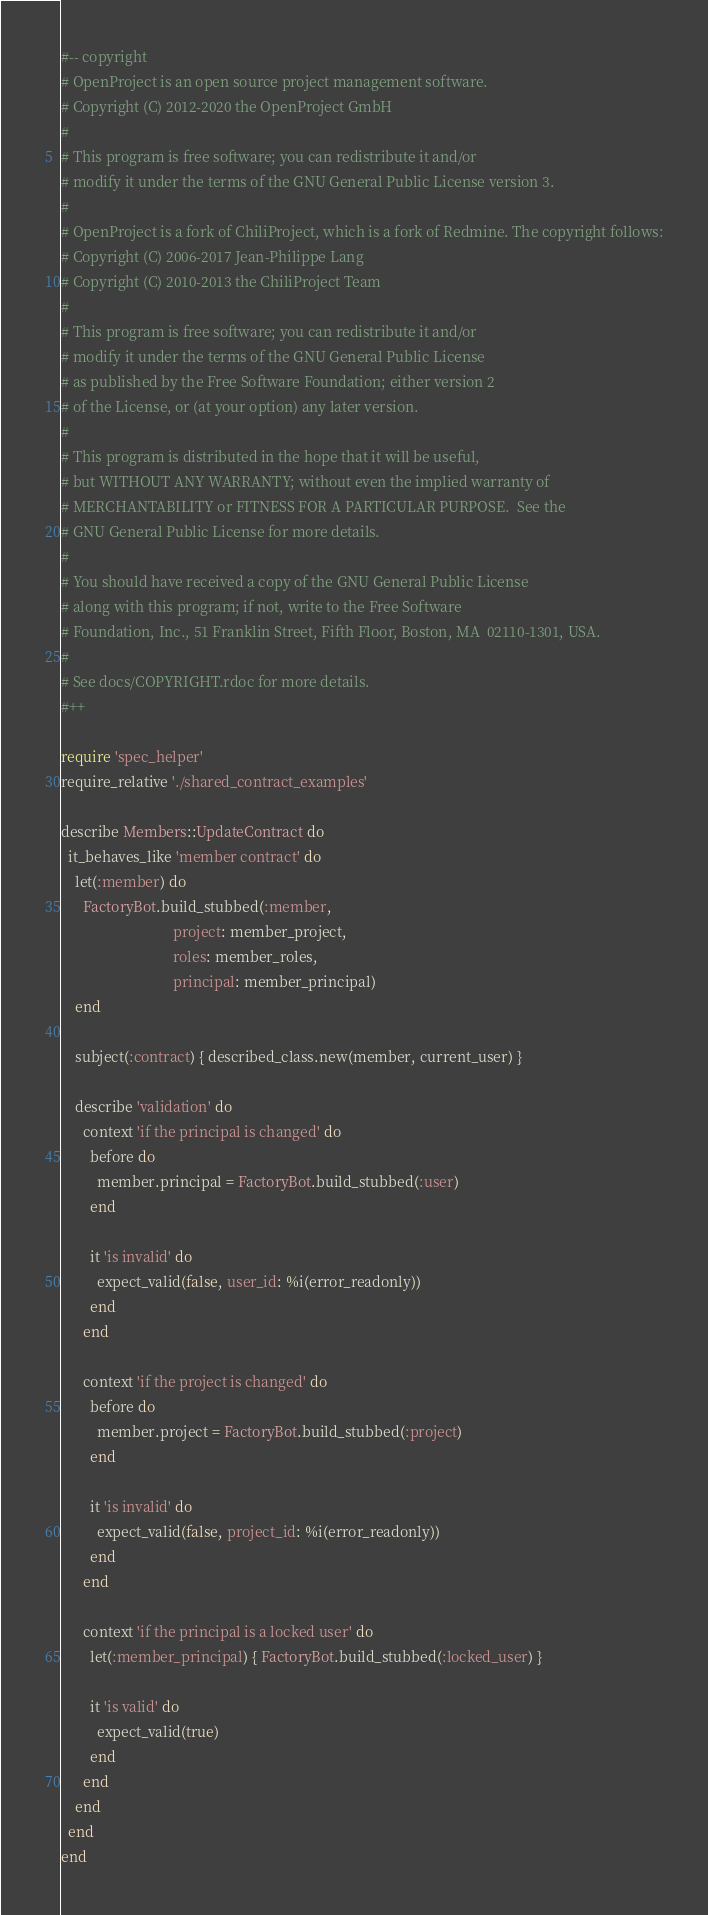Convert code to text. <code><loc_0><loc_0><loc_500><loc_500><_Ruby_>#-- copyright
# OpenProject is an open source project management software.
# Copyright (C) 2012-2020 the OpenProject GmbH
#
# This program is free software; you can redistribute it and/or
# modify it under the terms of the GNU General Public License version 3.
#
# OpenProject is a fork of ChiliProject, which is a fork of Redmine. The copyright follows:
# Copyright (C) 2006-2017 Jean-Philippe Lang
# Copyright (C) 2010-2013 the ChiliProject Team
#
# This program is free software; you can redistribute it and/or
# modify it under the terms of the GNU General Public License
# as published by the Free Software Foundation; either version 2
# of the License, or (at your option) any later version.
#
# This program is distributed in the hope that it will be useful,
# but WITHOUT ANY WARRANTY; without even the implied warranty of
# MERCHANTABILITY or FITNESS FOR A PARTICULAR PURPOSE.  See the
# GNU General Public License for more details.
#
# You should have received a copy of the GNU General Public License
# along with this program; if not, write to the Free Software
# Foundation, Inc., 51 Franklin Street, Fifth Floor, Boston, MA  02110-1301, USA.
#
# See docs/COPYRIGHT.rdoc for more details.
#++

require 'spec_helper'
require_relative './shared_contract_examples'

describe Members::UpdateContract do
  it_behaves_like 'member contract' do
    let(:member) do
      FactoryBot.build_stubbed(:member,
                               project: member_project,
                               roles: member_roles,
                               principal: member_principal)
    end

    subject(:contract) { described_class.new(member, current_user) }

    describe 'validation' do
      context 'if the principal is changed' do
        before do
          member.principal = FactoryBot.build_stubbed(:user)
        end

        it 'is invalid' do
          expect_valid(false, user_id: %i(error_readonly))
        end
      end

      context 'if the project is changed' do
        before do
          member.project = FactoryBot.build_stubbed(:project)
        end

        it 'is invalid' do
          expect_valid(false, project_id: %i(error_readonly))
        end
      end

      context 'if the principal is a locked user' do
        let(:member_principal) { FactoryBot.build_stubbed(:locked_user) }

        it 'is valid' do
          expect_valid(true)
        end
      end
    end
  end
end
</code> 